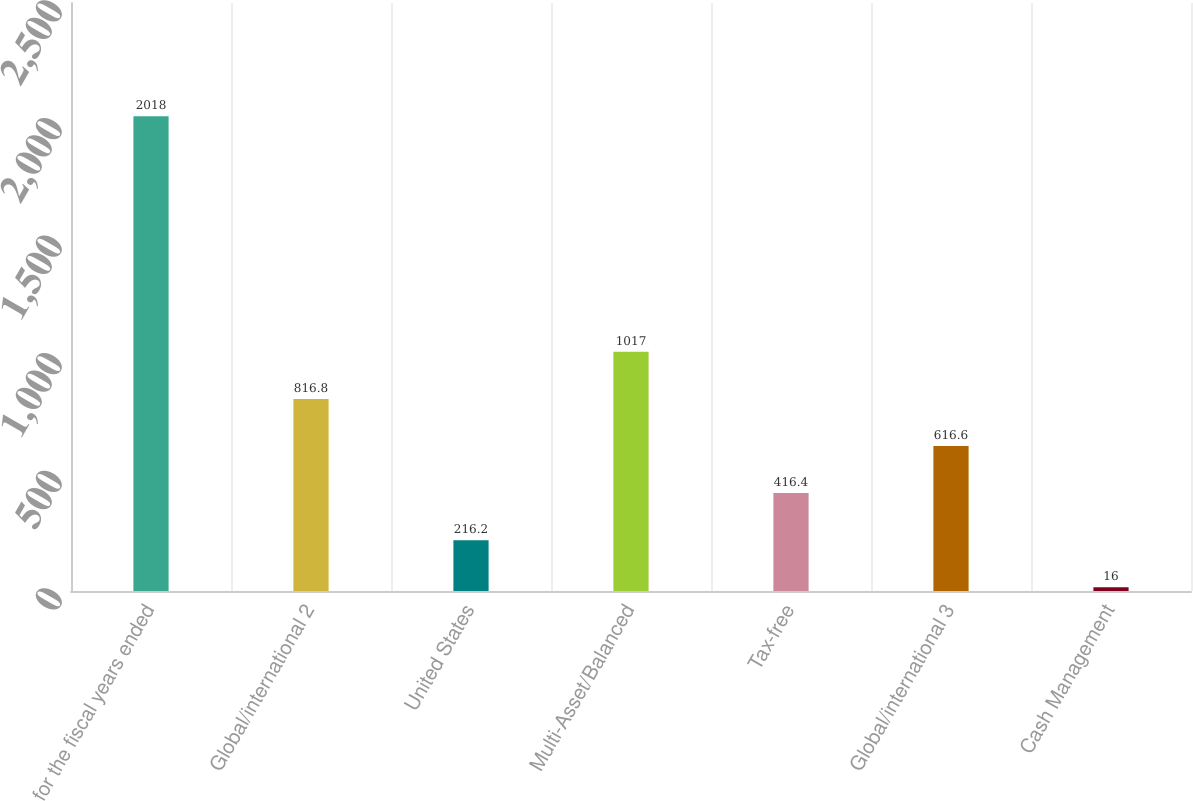Convert chart to OTSL. <chart><loc_0><loc_0><loc_500><loc_500><bar_chart><fcel>for the fiscal years ended<fcel>Global/international 2<fcel>United States<fcel>Multi-Asset/Balanced<fcel>Tax-free<fcel>Global/international 3<fcel>Cash Management<nl><fcel>2018<fcel>816.8<fcel>216.2<fcel>1017<fcel>416.4<fcel>616.6<fcel>16<nl></chart> 